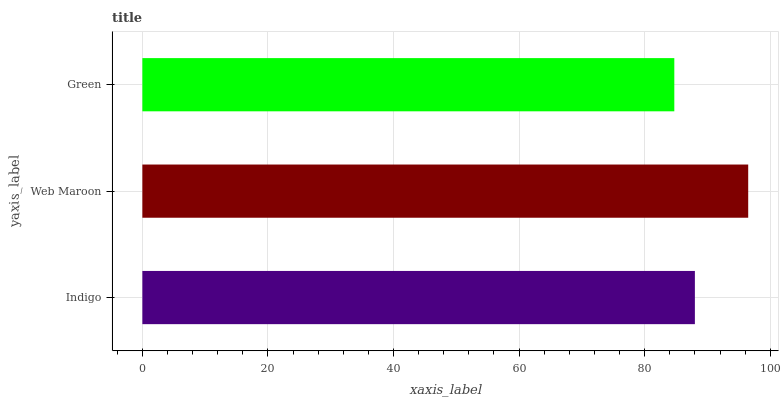Is Green the minimum?
Answer yes or no. Yes. Is Web Maroon the maximum?
Answer yes or no. Yes. Is Web Maroon the minimum?
Answer yes or no. No. Is Green the maximum?
Answer yes or no. No. Is Web Maroon greater than Green?
Answer yes or no. Yes. Is Green less than Web Maroon?
Answer yes or no. Yes. Is Green greater than Web Maroon?
Answer yes or no. No. Is Web Maroon less than Green?
Answer yes or no. No. Is Indigo the high median?
Answer yes or no. Yes. Is Indigo the low median?
Answer yes or no. Yes. Is Web Maroon the high median?
Answer yes or no. No. Is Web Maroon the low median?
Answer yes or no. No. 